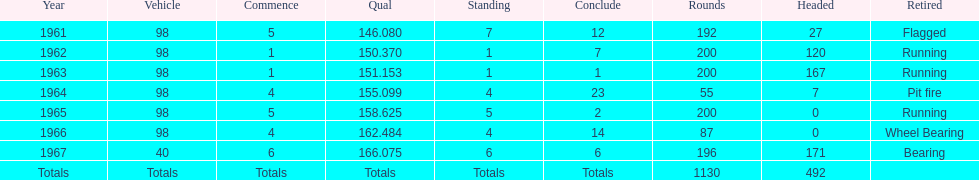What is the most common cause for a retired car? Running. 